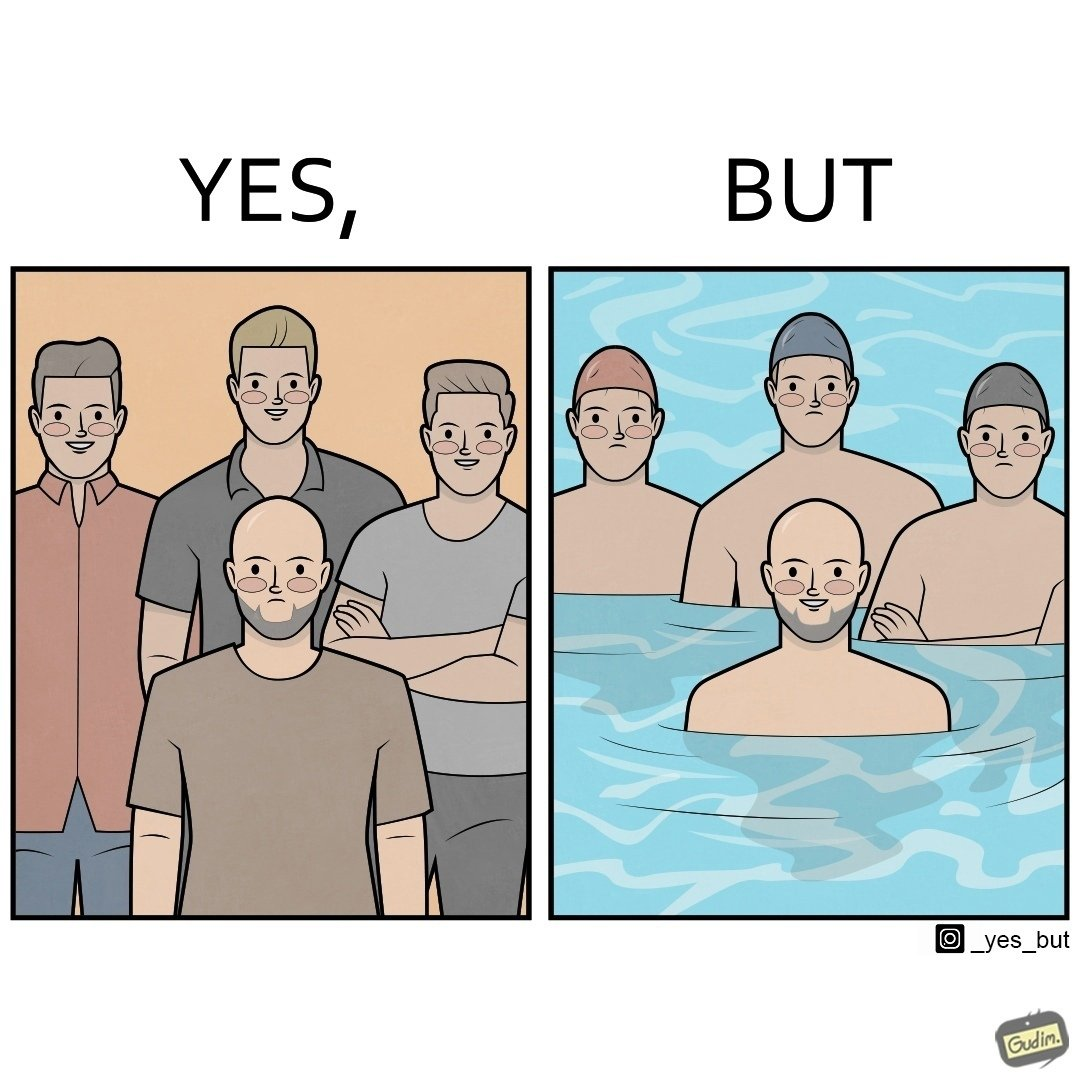What is shown in this image? The image is ironical, as person without hair is sad in a normal situation due to the absence of hair, unlike other people with hair. However, in a swimming pool, people with hair have to wear swimming caps, which is uncomfortable, while the person without hair does not need a cap, and is thus, happy in this situation. 